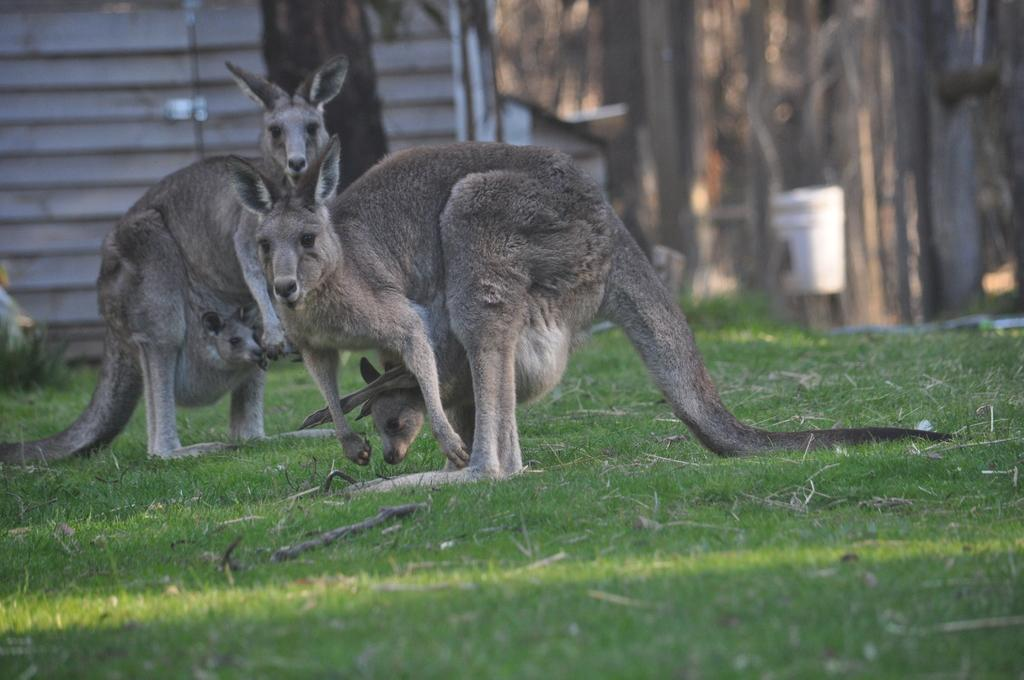What animals are present in the image? There are two kangaroos in the image. What is the kangaroos' position in the image? The kangaroos are standing on the grass. Are there any baby kangaroos in the image? Yes, there are babies in the kangaroos' pockets. Can you describe the background of the image? The background of the image is blurry. What type of spark can be seen coming from the bike in the image? There is no bike present in the image, so there cannot be any spark coming from it. 